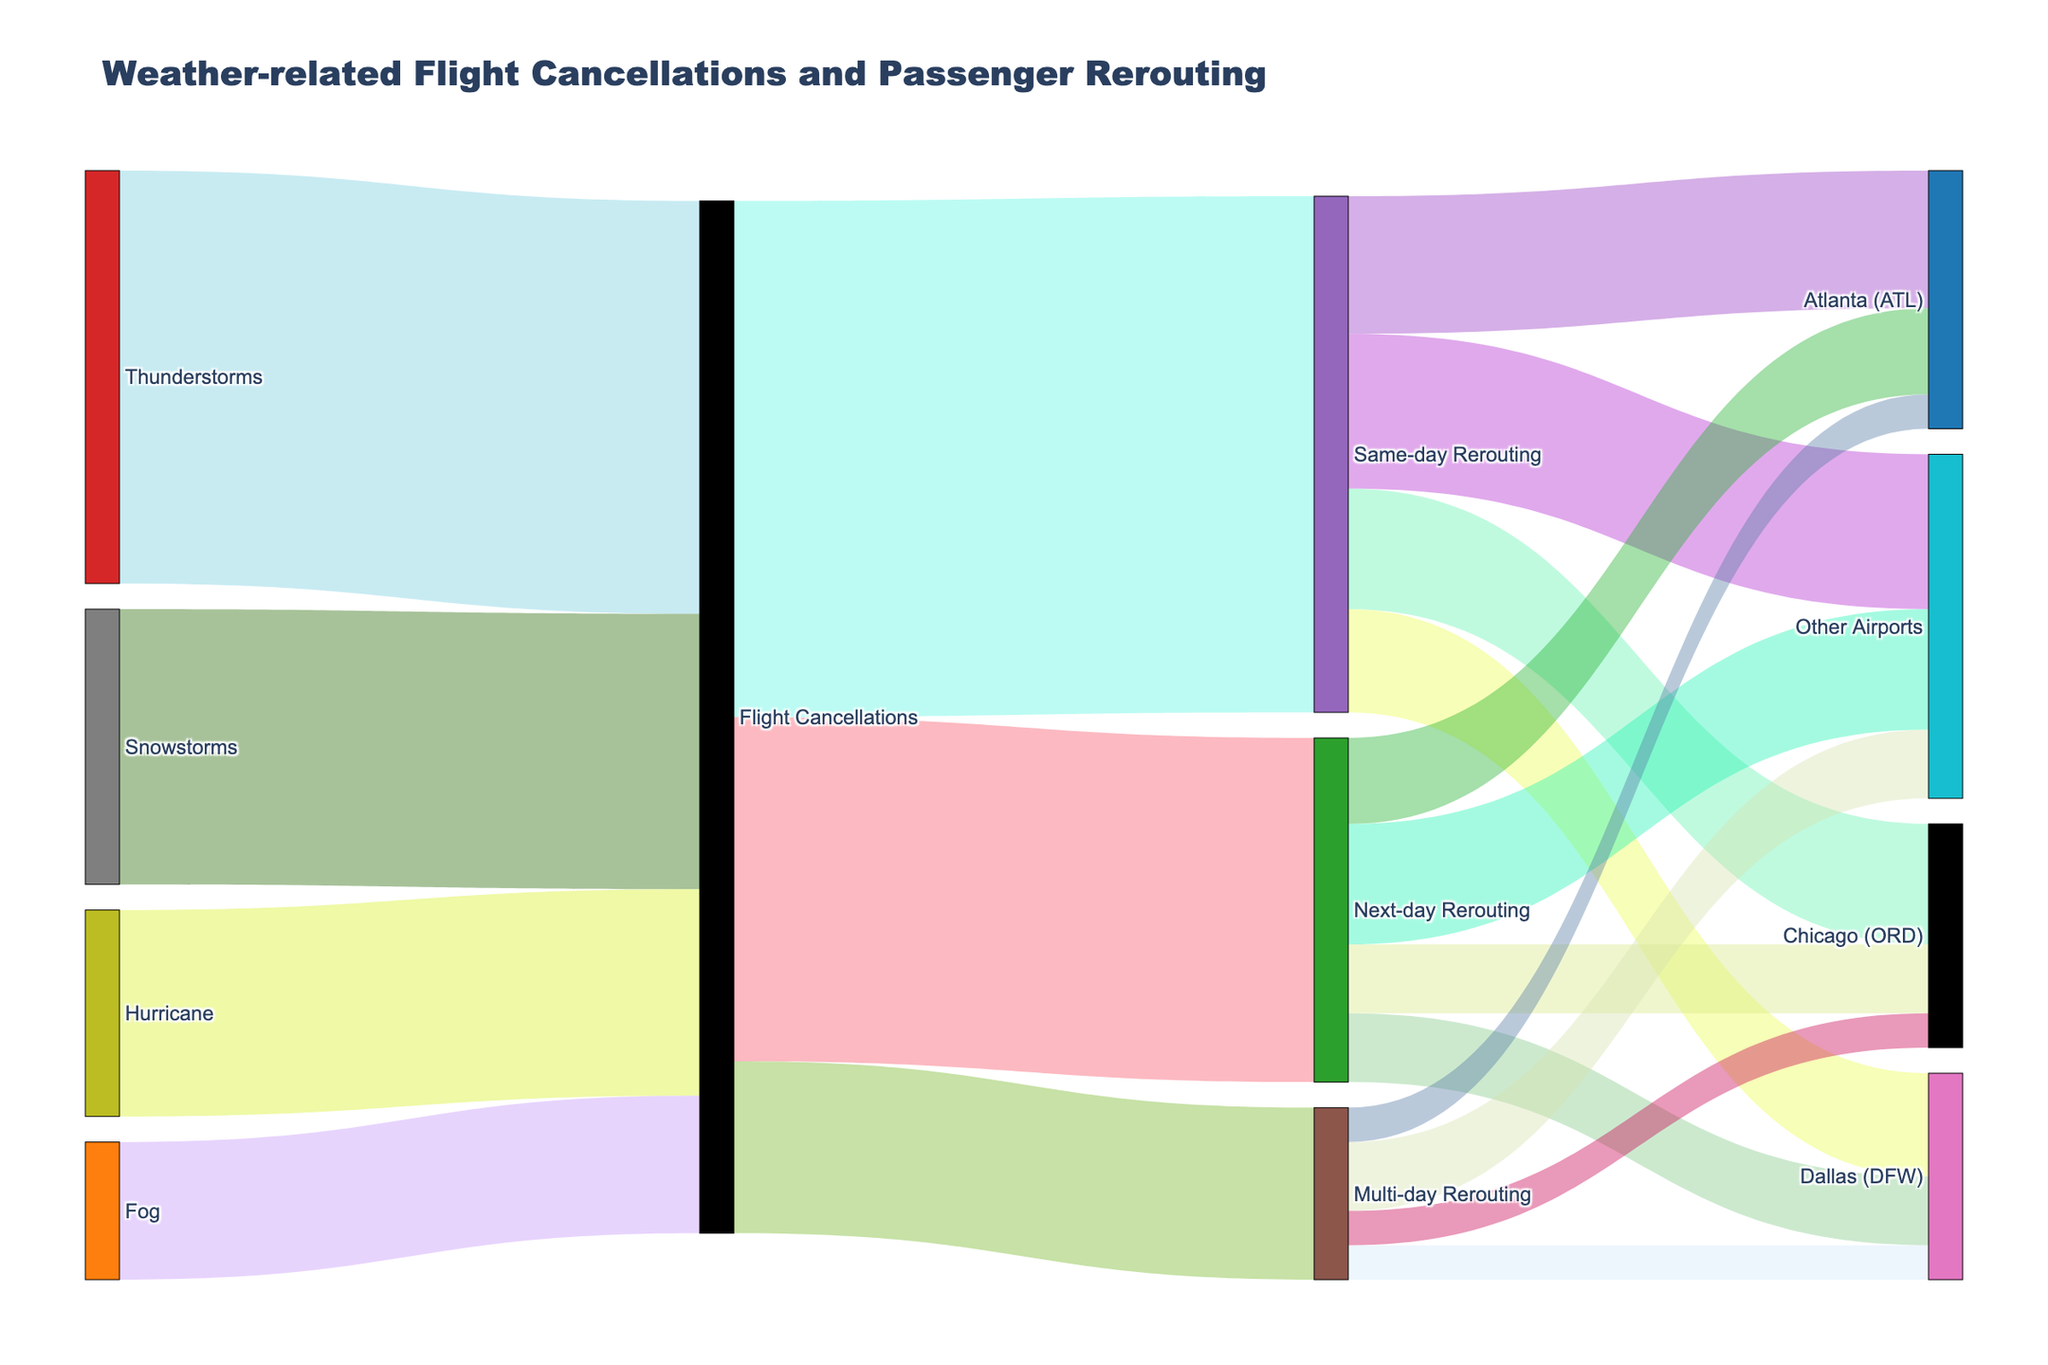What's the title of the diagram? Referring to the figure, the title is usually at the top above the plot area.
Answer: "Weather-related Flight Cancellations and Passenger Rerouting" How many flights were canceled due to thunderstorms? In the figure, find the link labeled 'Thunderstorms' leading to 'Flight Cancellations' and note the value.
Answer: 1200 Which weather event caused the fewest flight cancellations? Identify the weather-related sources leading to 'Flight Cancellations' and compare their values. 'Fog' has the smallest value.
Answer: Fog What is the total number of flight cancellations shown in the diagram? Sum up all the values from weather-related sources leading to 'Flight Cancellations': 1200 (Thunderstorms) + 800 (Snowstorms) + 400 (Fog) + 600 (Hurricane) = 3000
Answer: 3000 How many passengers were rerouted to Dallas (DFW) on a same-day basis? Locate the 'Same-day Rerouting' row and find the link directed to 'Dallas (DFW)' and note the value.
Answer: 300 What is the difference in the number of reroutings to Atlanta (ATL) on the same day versus the next day? Compare the values leading to 'Atlanta (ATL)' from 'Same-day Rerouting' (400) and 'Next-day Rerouting' (250). Subtract the smaller from the larger: 400 - 250 = 150
Answer: 150 Which rerouting category has the highest number of passengers going to 'Other Airports'? Examine the values of 'Same-day Rerouting', 'Next-day Rerouting', and 'Multi-day Rerouting' leading to 'Other Airports'. The highest is 'Same-day Rerouting' with 450.
Answer: Same-day Rerouting How many passengers required multi-day rerouting? Look at the links leading from 'Flight Cancellations' to 'Multi-day Rerouting' and note the value.
Answer: 500 What is the total number of passengers rerouted to Chicago (ORD) regardless of the rerouting type? Add up the values leading to 'Chicago (ORD)' from 'Same-day Rerouting' (350), 'Next-day Rerouting' (200), and 'Multi-day Rerouting' (100): 350 + 200 + 100 = 650
Answer: 650 What proportion of total rerouting effort (1500 same-day + 1000 next-day + 500 multi-day) goes into multi-day rerouting? Calculate the proportion: Multi-day Rerouting / Total Rerouting Effort. 500 / (1500 + 1000 + 500) = 500 / 3000 = 1/6, which is approximately 16.67%.
Answer: 16.67% 